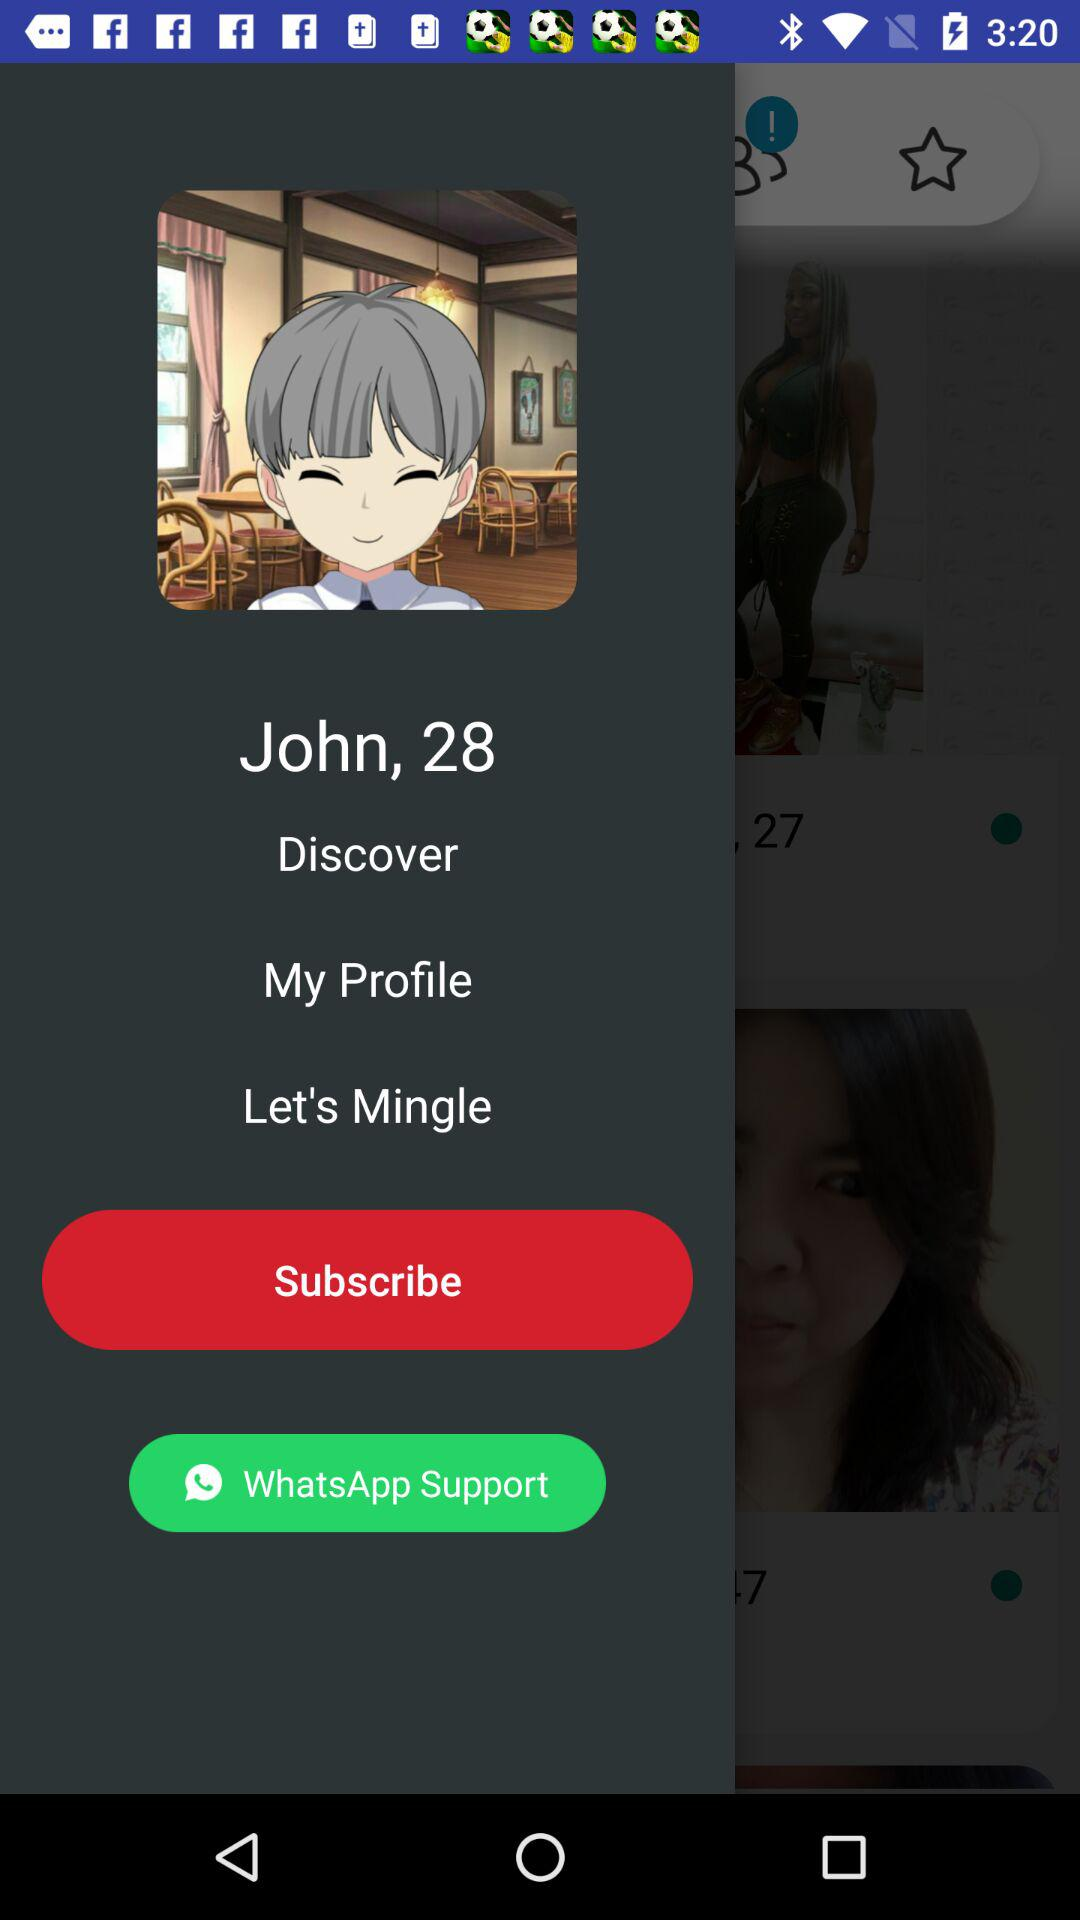What is the age? The age is 28. 